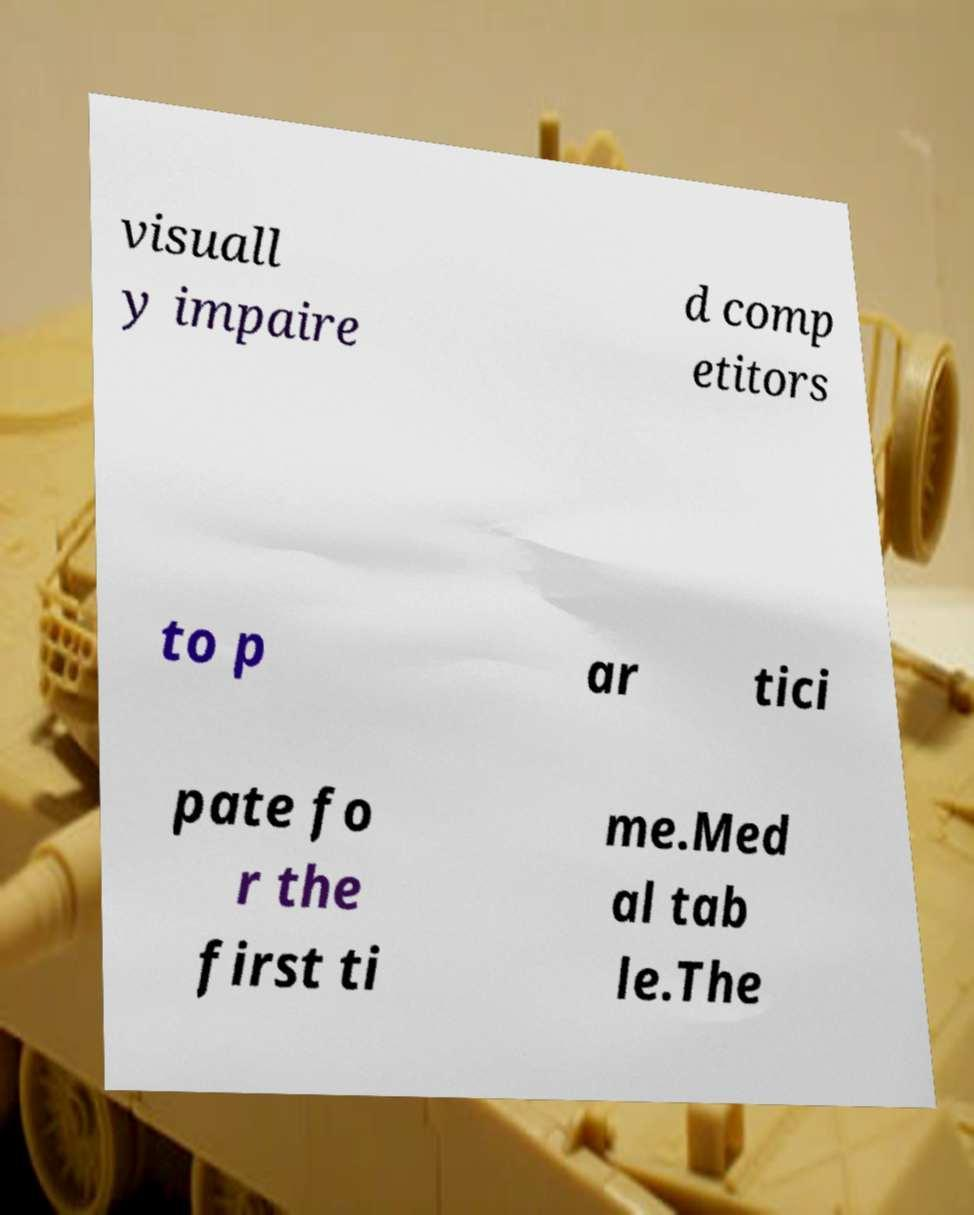Please read and relay the text visible in this image. What does it say? visuall y impaire d comp etitors to p ar tici pate fo r the first ti me.Med al tab le.The 